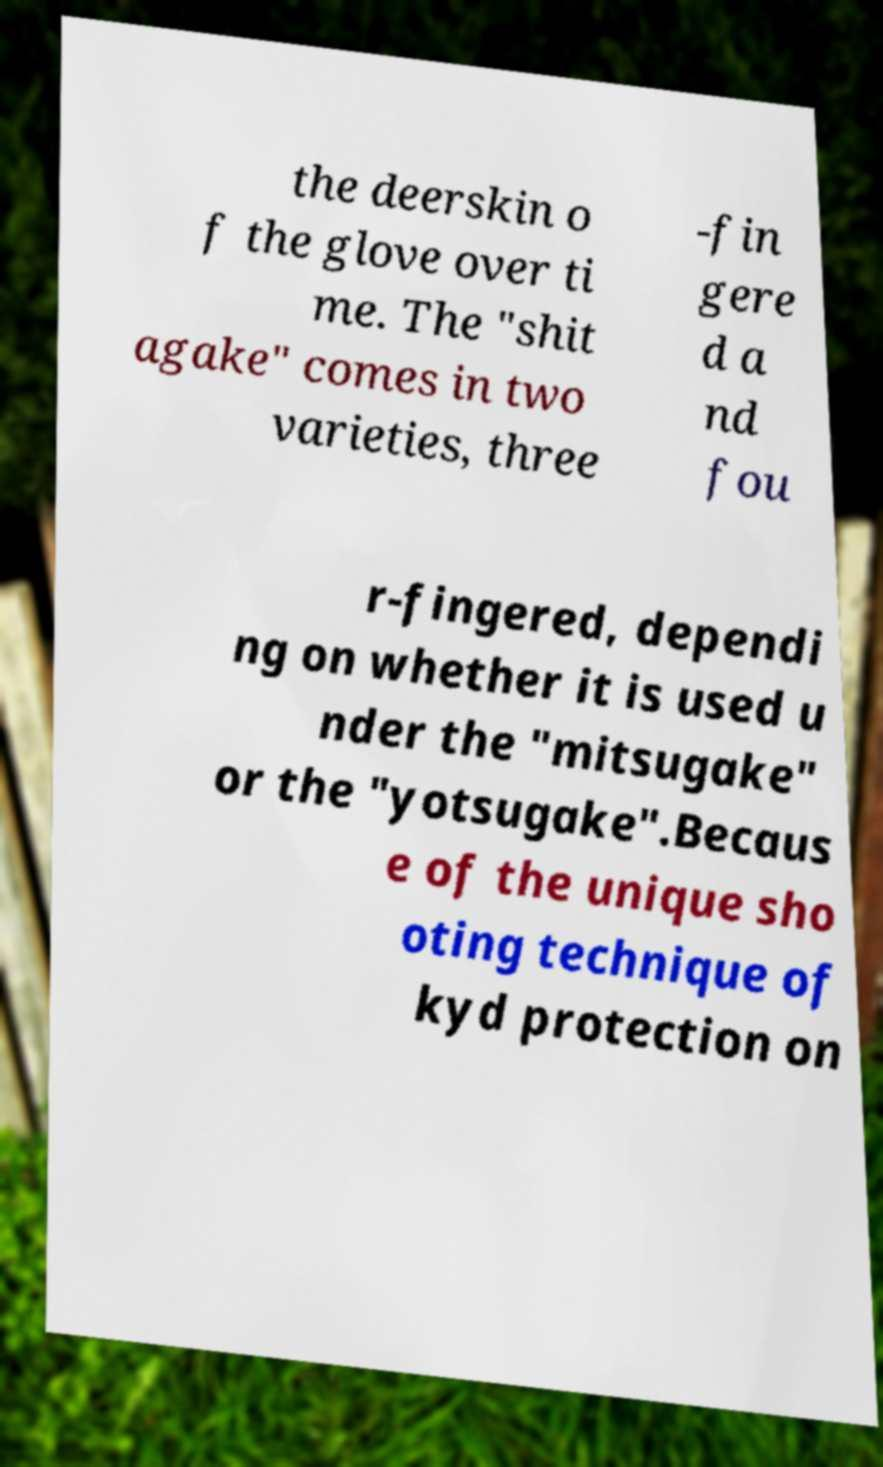For documentation purposes, I need the text within this image transcribed. Could you provide that? the deerskin o f the glove over ti me. The "shit agake" comes in two varieties, three -fin gere d a nd fou r-fingered, dependi ng on whether it is used u nder the "mitsugake" or the "yotsugake".Becaus e of the unique sho oting technique of kyd protection on 